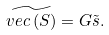Convert formula to latex. <formula><loc_0><loc_0><loc_500><loc_500>\widetilde { v e c \left ( S \right ) } = G \tilde { s } .</formula> 